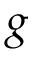<formula> <loc_0><loc_0><loc_500><loc_500>g</formula> 